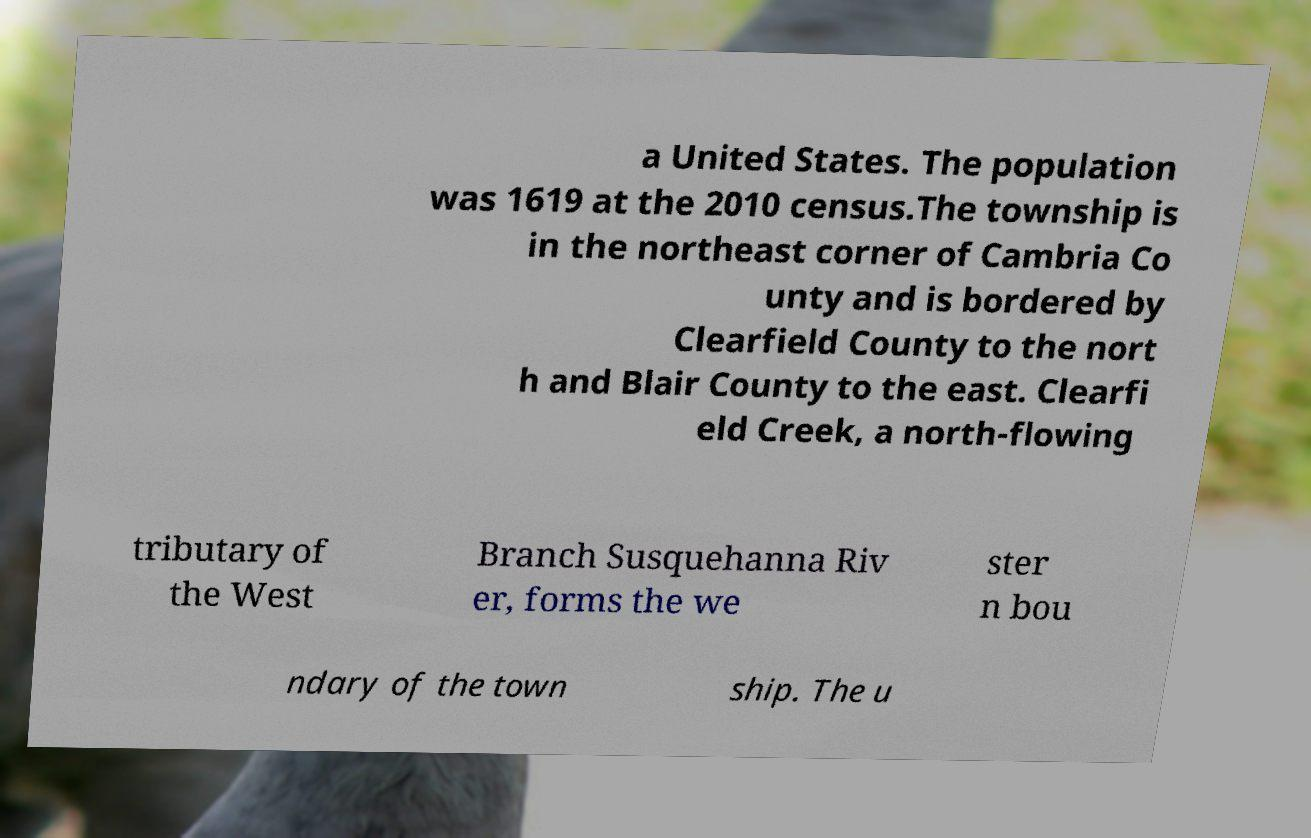For documentation purposes, I need the text within this image transcribed. Could you provide that? a United States. The population was 1619 at the 2010 census.The township is in the northeast corner of Cambria Co unty and is bordered by Clearfield County to the nort h and Blair County to the east. Clearfi eld Creek, a north-flowing tributary of the West Branch Susquehanna Riv er, forms the we ster n bou ndary of the town ship. The u 